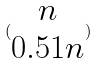Convert formula to latex. <formula><loc_0><loc_0><loc_500><loc_500>( \begin{matrix} n \\ 0 . 5 1 n \end{matrix} )</formula> 